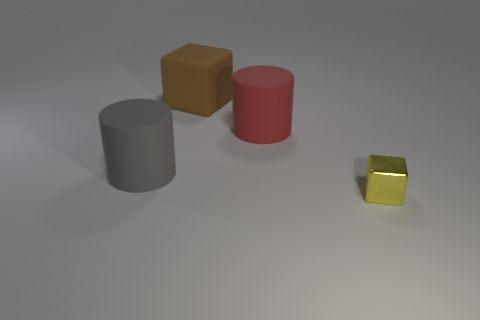Is there any other thing that has the same material as the tiny yellow block?
Ensure brevity in your answer.  No. What number of red cylinders are in front of the brown matte block?
Your answer should be compact. 1. The large cylinder that is the same material as the big gray object is what color?
Make the answer very short. Red. There is a brown rubber object; does it have the same size as the matte cylinder that is behind the gray object?
Give a very brief answer. Yes. There is a matte cylinder in front of the rubber cylinder that is behind the cylinder that is left of the large red rubber cylinder; what is its size?
Provide a short and direct response. Large. How many metallic objects are either big red cylinders or large brown things?
Make the answer very short. 0. There is a cube that is in front of the large red rubber object; what is its color?
Ensure brevity in your answer.  Yellow. What is the shape of the red matte thing that is the same size as the gray rubber cylinder?
Your response must be concise. Cylinder. Does the small cube have the same color as the large object that is in front of the red matte cylinder?
Provide a short and direct response. No. What number of things are cubes that are behind the tiny yellow cube or blocks that are in front of the large brown rubber object?
Offer a very short reply. 2. 